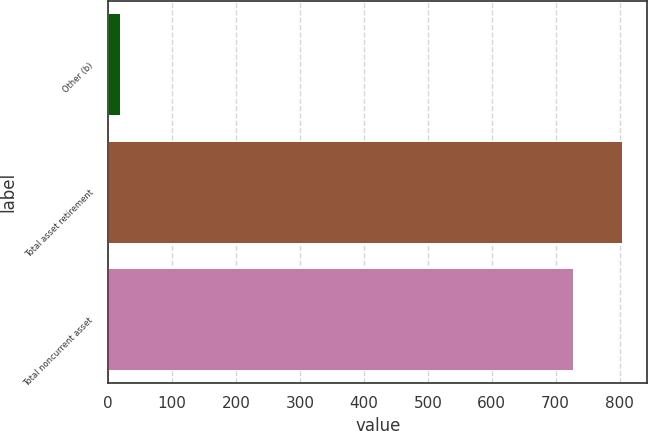<chart> <loc_0><loc_0><loc_500><loc_500><bar_chart><fcel>Other (b)<fcel>Total asset retirement<fcel>Total noncurrent asset<nl><fcel>18<fcel>803.3<fcel>727<nl></chart> 